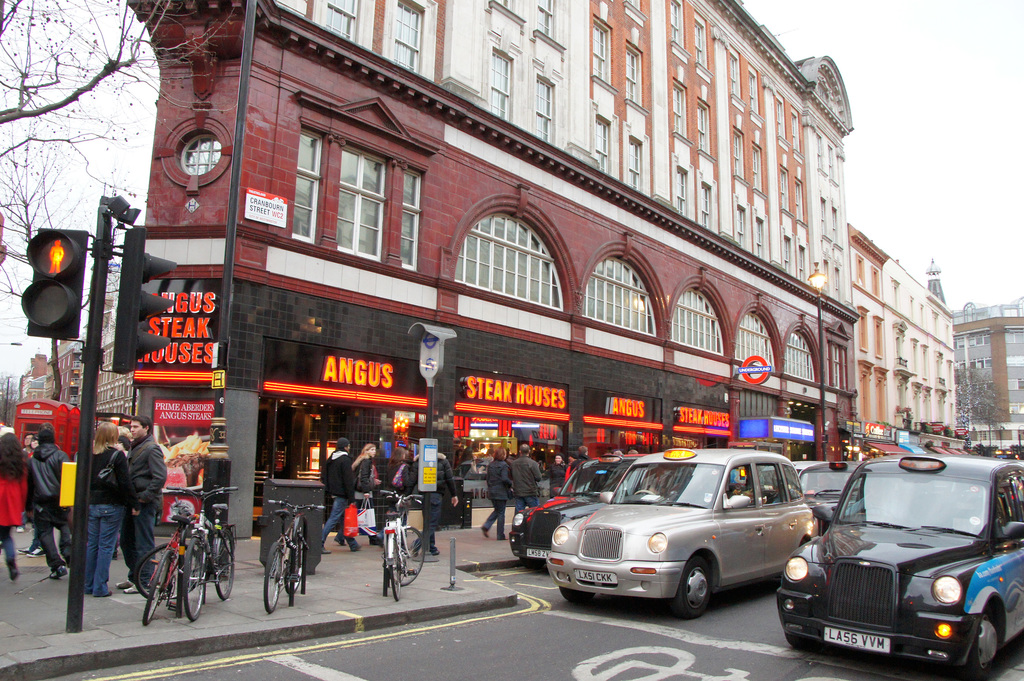Explore the architectural styles present in the image. The architecture in the image showcases a fascinating mix of styles. The prominent red-brick building hosting the steak houses features classical architectural details, including large, symmetrically arranged windows and decorative brickwork, indicative of Victorian era design. This contrasts with simpler, more modern facades seen in the background, highlighting the architectural diversity and historical layers of the area. 